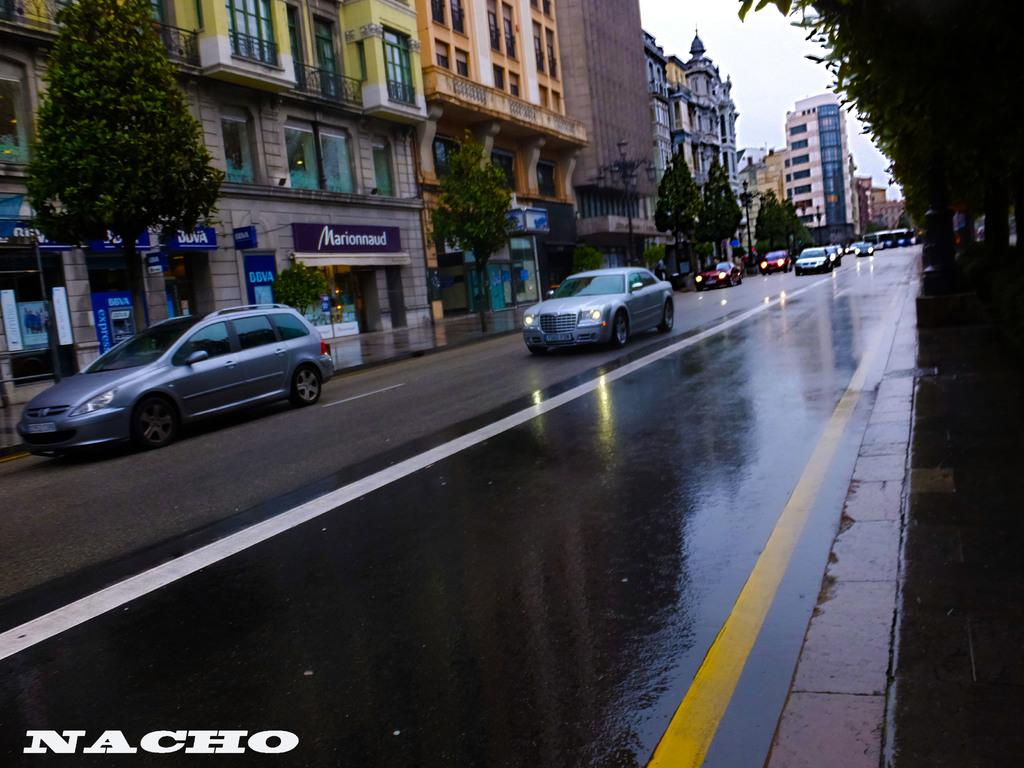What is the main subject of the image? The main subject of the image is cars on a road. What can be seen on either side of the road? There are trees on either side of the road. What is visible in the background of the image? There are buildings in the background of the image. Where is the text located in the image? The text is in the bottom left corner of the image. What type of fang can be seen in the image? There is no fang present in the image. What kind of silk is used to make the buildings in the image? The buildings in the image are not made of silk, and therefore no silk is present. 